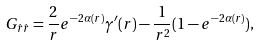<formula> <loc_0><loc_0><loc_500><loc_500>G _ { \hat { r } \hat { r } } = \frac { 2 } { r } e ^ { - 2 \alpha ( r ) } \gamma ^ { \prime } ( r ) - \frac { 1 } { r ^ { 2 } } ( 1 - e ^ { - 2 \alpha ( r ) } ) ,</formula> 